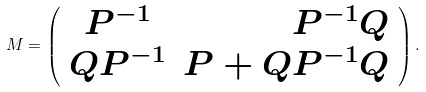Convert formula to latex. <formula><loc_0><loc_0><loc_500><loc_500>M = \left ( \begin{array} { c r c } P ^ { - 1 } & P ^ { - 1 } Q \\ Q P ^ { - 1 } & P + Q P ^ { - 1 } Q \\ \end{array} \right ) .</formula> 